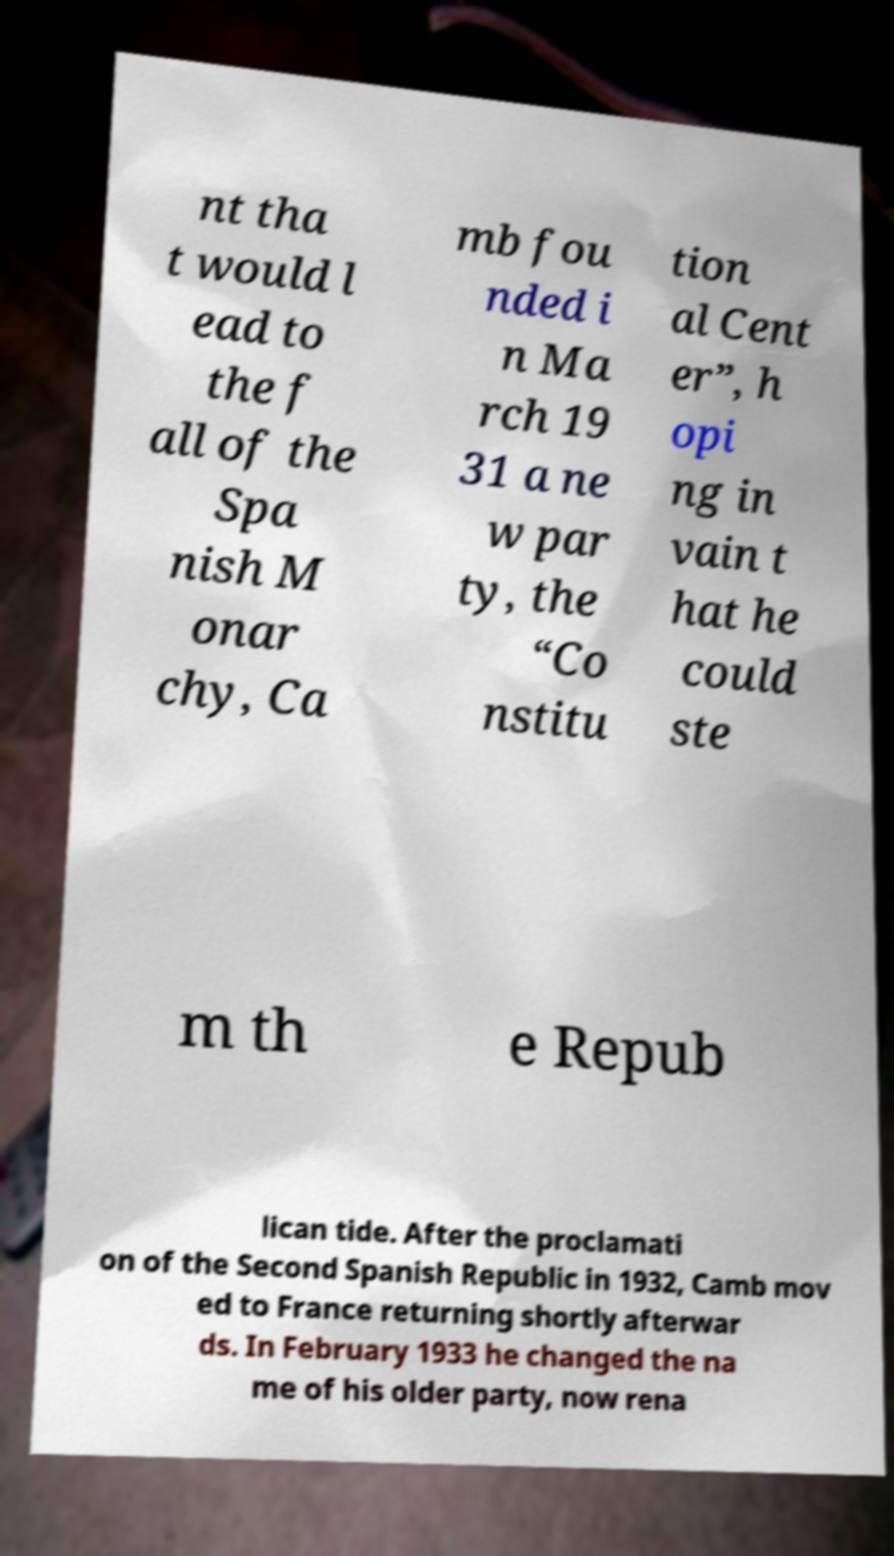Could you extract and type out the text from this image? nt tha t would l ead to the f all of the Spa nish M onar chy, Ca mb fou nded i n Ma rch 19 31 a ne w par ty, the “Co nstitu tion al Cent er”, h opi ng in vain t hat he could ste m th e Repub lican tide. After the proclamati on of the Second Spanish Republic in 1932, Camb mov ed to France returning shortly afterwar ds. In February 1933 he changed the na me of his older party, now rena 